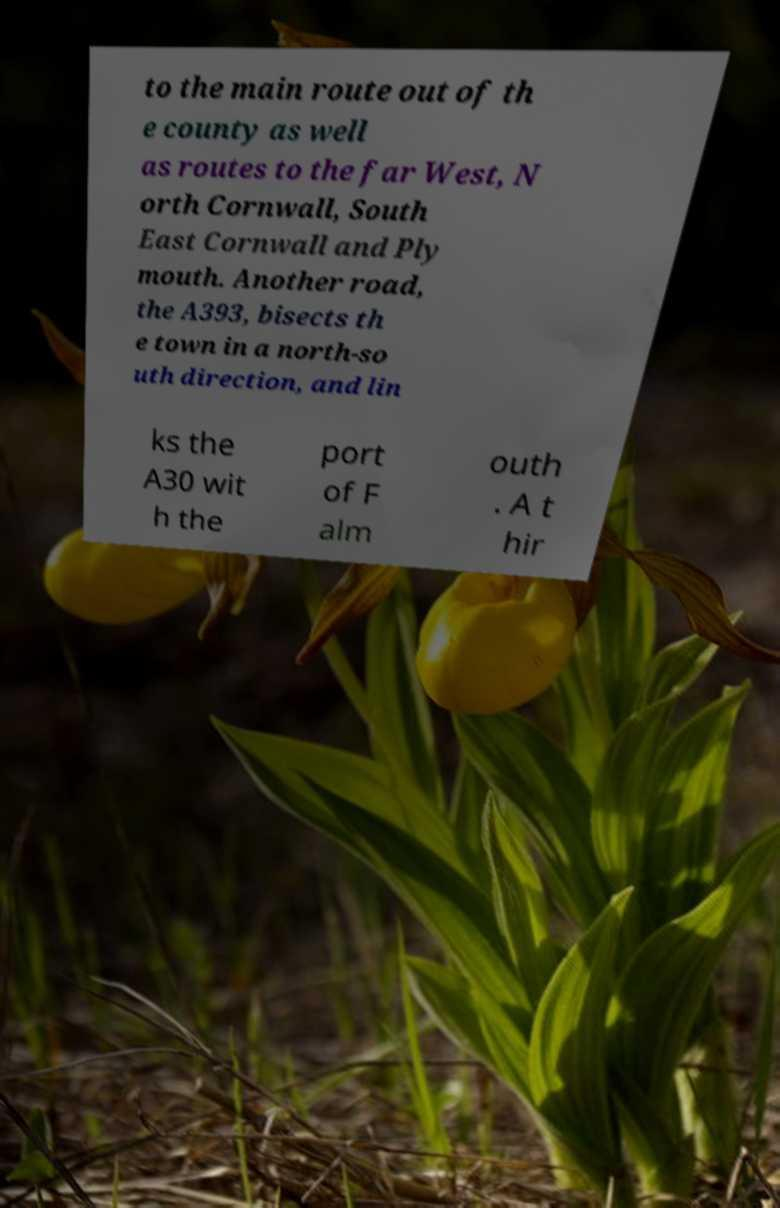Could you extract and type out the text from this image? to the main route out of th e county as well as routes to the far West, N orth Cornwall, South East Cornwall and Ply mouth. Another road, the A393, bisects th e town in a north-so uth direction, and lin ks the A30 wit h the port of F alm outh . A t hir 